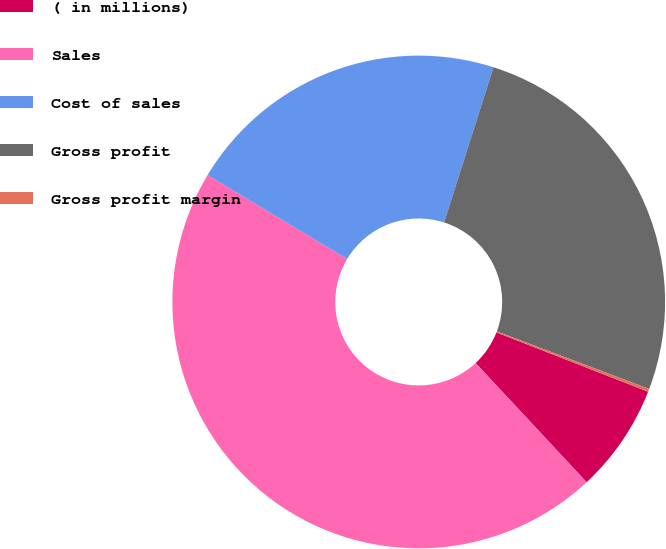<chart> <loc_0><loc_0><loc_500><loc_500><pie_chart><fcel>( in millions)<fcel>Sales<fcel>Cost of sales<fcel>Gross profit<fcel>Gross profit margin<nl><fcel>7.13%<fcel>45.55%<fcel>21.3%<fcel>25.84%<fcel>0.19%<nl></chart> 